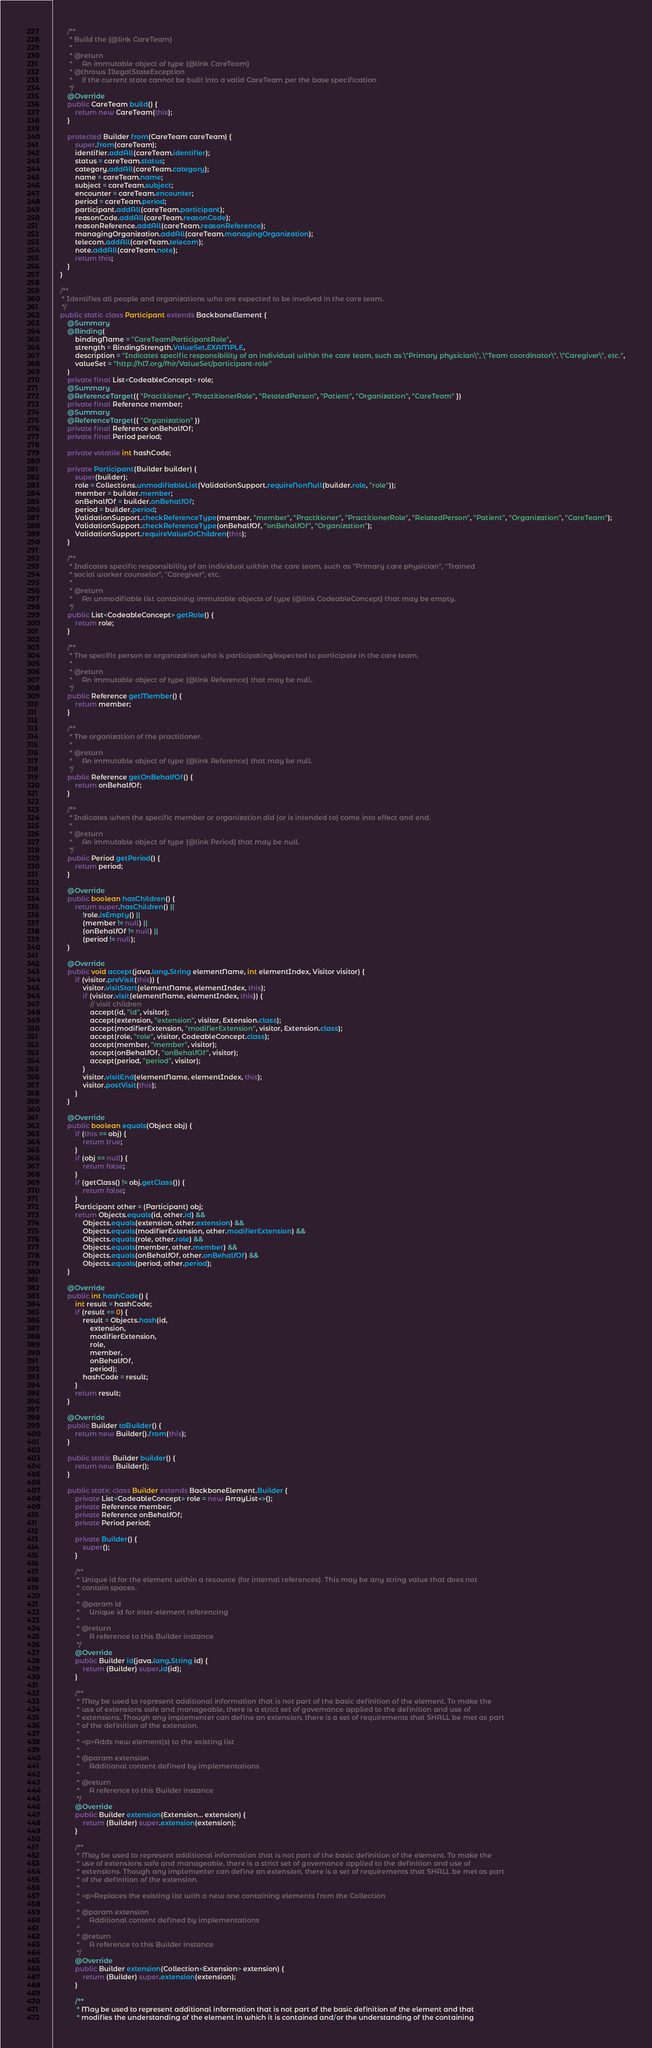Convert code to text. <code><loc_0><loc_0><loc_500><loc_500><_Java_>        /**
         * Build the {@link CareTeam}
         * 
         * @return
         *     An immutable object of type {@link CareTeam}
         * @throws IllegalStateException
         *     if the current state cannot be built into a valid CareTeam per the base specification
         */
        @Override
        public CareTeam build() {
            return new CareTeam(this);
        }

        protected Builder from(CareTeam careTeam) {
            super.from(careTeam);
            identifier.addAll(careTeam.identifier);
            status = careTeam.status;
            category.addAll(careTeam.category);
            name = careTeam.name;
            subject = careTeam.subject;
            encounter = careTeam.encounter;
            period = careTeam.period;
            participant.addAll(careTeam.participant);
            reasonCode.addAll(careTeam.reasonCode);
            reasonReference.addAll(careTeam.reasonReference);
            managingOrganization.addAll(careTeam.managingOrganization);
            telecom.addAll(careTeam.telecom);
            note.addAll(careTeam.note);
            return this;
        }
    }

    /**
     * Identifies all people and organizations who are expected to be involved in the care team.
     */
    public static class Participant extends BackboneElement {
        @Summary
        @Binding(
            bindingName = "CareTeamParticipantRole",
            strength = BindingStrength.ValueSet.EXAMPLE,
            description = "Indicates specific responsibility of an individual within the care team, such as \"Primary physician\", \"Team coordinator\", \"Caregiver\", etc.",
            valueSet = "http://hl7.org/fhir/ValueSet/participant-role"
        )
        private final List<CodeableConcept> role;
        @Summary
        @ReferenceTarget({ "Practitioner", "PractitionerRole", "RelatedPerson", "Patient", "Organization", "CareTeam" })
        private final Reference member;
        @Summary
        @ReferenceTarget({ "Organization" })
        private final Reference onBehalfOf;
        private final Period period;

        private volatile int hashCode;

        private Participant(Builder builder) {
            super(builder);
            role = Collections.unmodifiableList(ValidationSupport.requireNonNull(builder.role, "role"));
            member = builder.member;
            onBehalfOf = builder.onBehalfOf;
            period = builder.period;
            ValidationSupport.checkReferenceType(member, "member", "Practitioner", "PractitionerRole", "RelatedPerson", "Patient", "Organization", "CareTeam");
            ValidationSupport.checkReferenceType(onBehalfOf, "onBehalfOf", "Organization");
            ValidationSupport.requireValueOrChildren(this);
        }

        /**
         * Indicates specific responsibility of an individual within the care team, such as "Primary care physician", "Trained 
         * social worker counselor", "Caregiver", etc.
         * 
         * @return
         *     An unmodifiable list containing immutable objects of type {@link CodeableConcept} that may be empty.
         */
        public List<CodeableConcept> getRole() {
            return role;
        }

        /**
         * The specific person or organization who is participating/expected to participate in the care team.
         * 
         * @return
         *     An immutable object of type {@link Reference} that may be null.
         */
        public Reference getMember() {
            return member;
        }

        /**
         * The organization of the practitioner.
         * 
         * @return
         *     An immutable object of type {@link Reference} that may be null.
         */
        public Reference getOnBehalfOf() {
            return onBehalfOf;
        }

        /**
         * Indicates when the specific member or organization did (or is intended to) come into effect and end.
         * 
         * @return
         *     An immutable object of type {@link Period} that may be null.
         */
        public Period getPeriod() {
            return period;
        }

        @Override
        public boolean hasChildren() {
            return super.hasChildren() || 
                !role.isEmpty() || 
                (member != null) || 
                (onBehalfOf != null) || 
                (period != null);
        }

        @Override
        public void accept(java.lang.String elementName, int elementIndex, Visitor visitor) {
            if (visitor.preVisit(this)) {
                visitor.visitStart(elementName, elementIndex, this);
                if (visitor.visit(elementName, elementIndex, this)) {
                    // visit children
                    accept(id, "id", visitor);
                    accept(extension, "extension", visitor, Extension.class);
                    accept(modifierExtension, "modifierExtension", visitor, Extension.class);
                    accept(role, "role", visitor, CodeableConcept.class);
                    accept(member, "member", visitor);
                    accept(onBehalfOf, "onBehalfOf", visitor);
                    accept(period, "period", visitor);
                }
                visitor.visitEnd(elementName, elementIndex, this);
                visitor.postVisit(this);
            }
        }

        @Override
        public boolean equals(Object obj) {
            if (this == obj) {
                return true;
            }
            if (obj == null) {
                return false;
            }
            if (getClass() != obj.getClass()) {
                return false;
            }
            Participant other = (Participant) obj;
            return Objects.equals(id, other.id) && 
                Objects.equals(extension, other.extension) && 
                Objects.equals(modifierExtension, other.modifierExtension) && 
                Objects.equals(role, other.role) && 
                Objects.equals(member, other.member) && 
                Objects.equals(onBehalfOf, other.onBehalfOf) && 
                Objects.equals(period, other.period);
        }

        @Override
        public int hashCode() {
            int result = hashCode;
            if (result == 0) {
                result = Objects.hash(id, 
                    extension, 
                    modifierExtension, 
                    role, 
                    member, 
                    onBehalfOf, 
                    period);
                hashCode = result;
            }
            return result;
        }

        @Override
        public Builder toBuilder() {
            return new Builder().from(this);
        }

        public static Builder builder() {
            return new Builder();
        }

        public static class Builder extends BackboneElement.Builder {
            private List<CodeableConcept> role = new ArrayList<>();
            private Reference member;
            private Reference onBehalfOf;
            private Period period;

            private Builder() {
                super();
            }

            /**
             * Unique id for the element within a resource (for internal references). This may be any string value that does not 
             * contain spaces.
             * 
             * @param id
             *     Unique id for inter-element referencing
             * 
             * @return
             *     A reference to this Builder instance
             */
            @Override
            public Builder id(java.lang.String id) {
                return (Builder) super.id(id);
            }

            /**
             * May be used to represent additional information that is not part of the basic definition of the element. To make the 
             * use of extensions safe and manageable, there is a strict set of governance applied to the definition and use of 
             * extensions. Though any implementer can define an extension, there is a set of requirements that SHALL be met as part 
             * of the definition of the extension.
             * 
             * <p>Adds new element(s) to the existing list
             * 
             * @param extension
             *     Additional content defined by implementations
             * 
             * @return
             *     A reference to this Builder instance
             */
            @Override
            public Builder extension(Extension... extension) {
                return (Builder) super.extension(extension);
            }

            /**
             * May be used to represent additional information that is not part of the basic definition of the element. To make the 
             * use of extensions safe and manageable, there is a strict set of governance applied to the definition and use of 
             * extensions. Though any implementer can define an extension, there is a set of requirements that SHALL be met as part 
             * of the definition of the extension.
             * 
             * <p>Replaces the existing list with a new one containing elements from the Collection
             * 
             * @param extension
             *     Additional content defined by implementations
             * 
             * @return
             *     A reference to this Builder instance
             */
            @Override
            public Builder extension(Collection<Extension> extension) {
                return (Builder) super.extension(extension);
            }

            /**
             * May be used to represent additional information that is not part of the basic definition of the element and that 
             * modifies the understanding of the element in which it is contained and/or the understanding of the containing </code> 